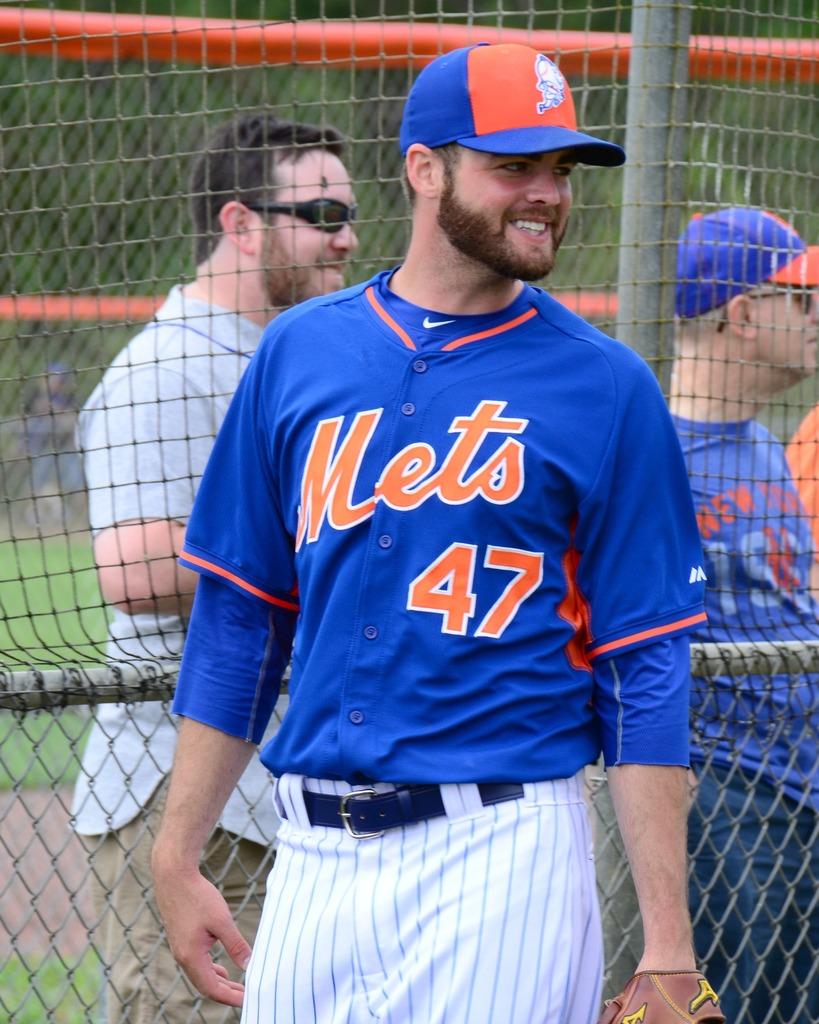What team does he play for?
Provide a short and direct response. Mets. What number is the mets player wearing?
Offer a terse response. 47. 